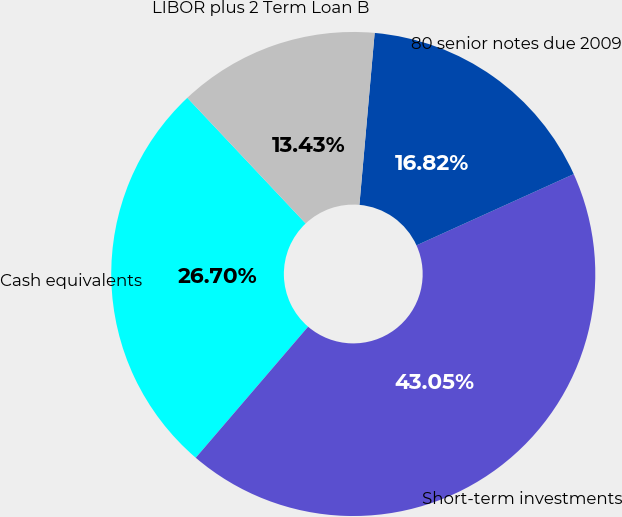Convert chart. <chart><loc_0><loc_0><loc_500><loc_500><pie_chart><fcel>Cash equivalents<fcel>Short-term investments<fcel>80 senior notes due 2009<fcel>LIBOR plus 2 Term Loan B<nl><fcel>26.7%<fcel>43.05%<fcel>16.82%<fcel>13.43%<nl></chart> 